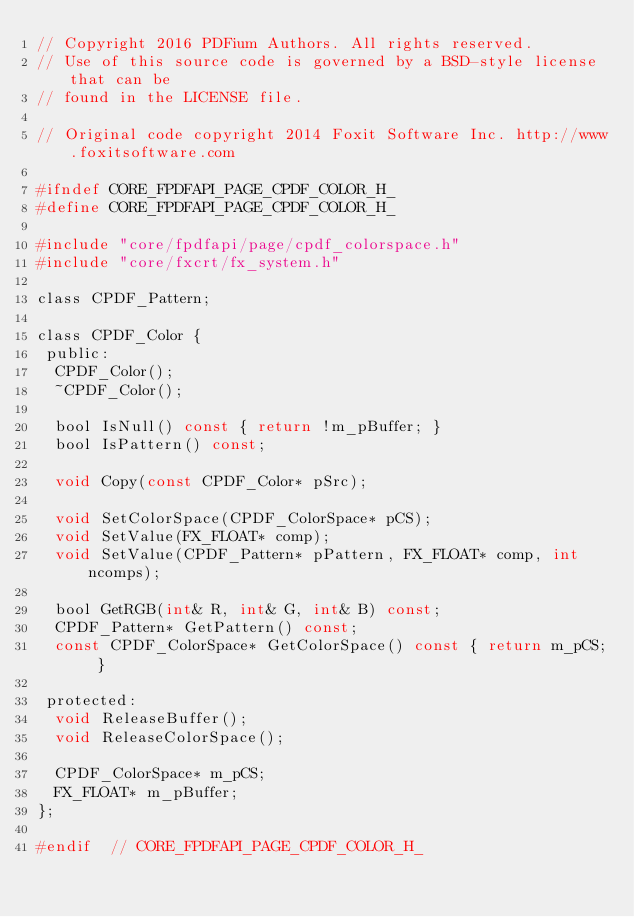<code> <loc_0><loc_0><loc_500><loc_500><_C_>// Copyright 2016 PDFium Authors. All rights reserved.
// Use of this source code is governed by a BSD-style license that can be
// found in the LICENSE file.

// Original code copyright 2014 Foxit Software Inc. http://www.foxitsoftware.com

#ifndef CORE_FPDFAPI_PAGE_CPDF_COLOR_H_
#define CORE_FPDFAPI_PAGE_CPDF_COLOR_H_

#include "core/fpdfapi/page/cpdf_colorspace.h"
#include "core/fxcrt/fx_system.h"

class CPDF_Pattern;

class CPDF_Color {
 public:
  CPDF_Color();
  ~CPDF_Color();

  bool IsNull() const { return !m_pBuffer; }
  bool IsPattern() const;

  void Copy(const CPDF_Color* pSrc);

  void SetColorSpace(CPDF_ColorSpace* pCS);
  void SetValue(FX_FLOAT* comp);
  void SetValue(CPDF_Pattern* pPattern, FX_FLOAT* comp, int ncomps);

  bool GetRGB(int& R, int& G, int& B) const;
  CPDF_Pattern* GetPattern() const;
  const CPDF_ColorSpace* GetColorSpace() const { return m_pCS; }

 protected:
  void ReleaseBuffer();
  void ReleaseColorSpace();

  CPDF_ColorSpace* m_pCS;
  FX_FLOAT* m_pBuffer;
};

#endif  // CORE_FPDFAPI_PAGE_CPDF_COLOR_H_
</code> 